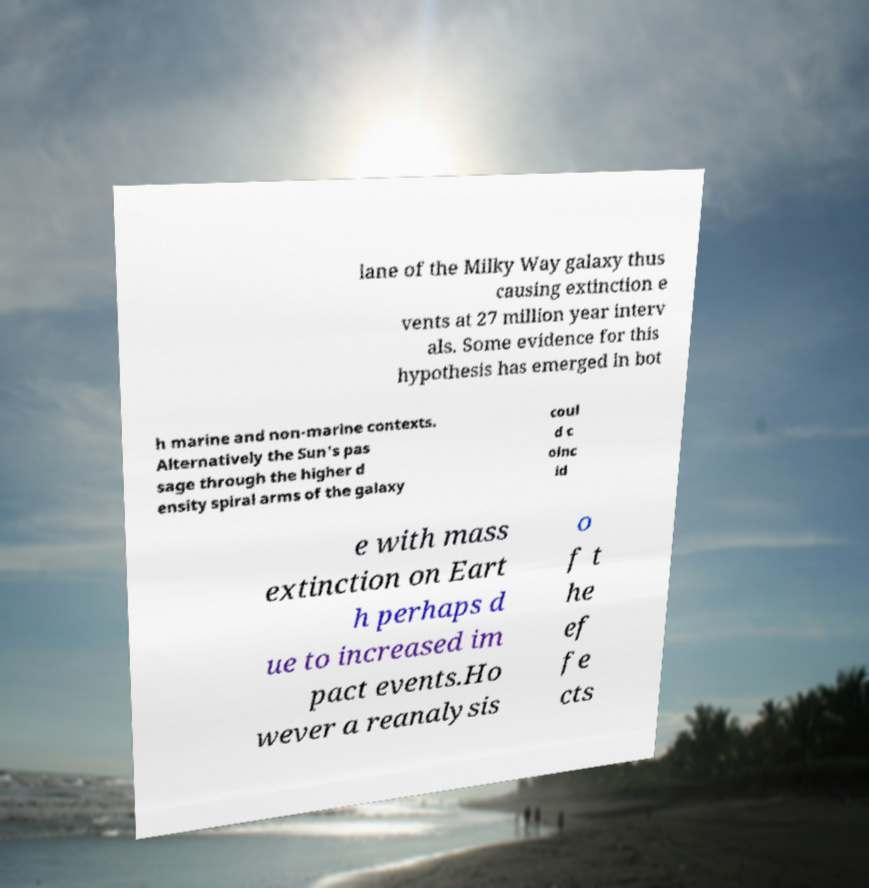Could you assist in decoding the text presented in this image and type it out clearly? lane of the Milky Way galaxy thus causing extinction e vents at 27 million year interv als. Some evidence for this hypothesis has emerged in bot h marine and non-marine contexts. Alternatively the Sun's pas sage through the higher d ensity spiral arms of the galaxy coul d c oinc id e with mass extinction on Eart h perhaps d ue to increased im pact events.Ho wever a reanalysis o f t he ef fe cts 